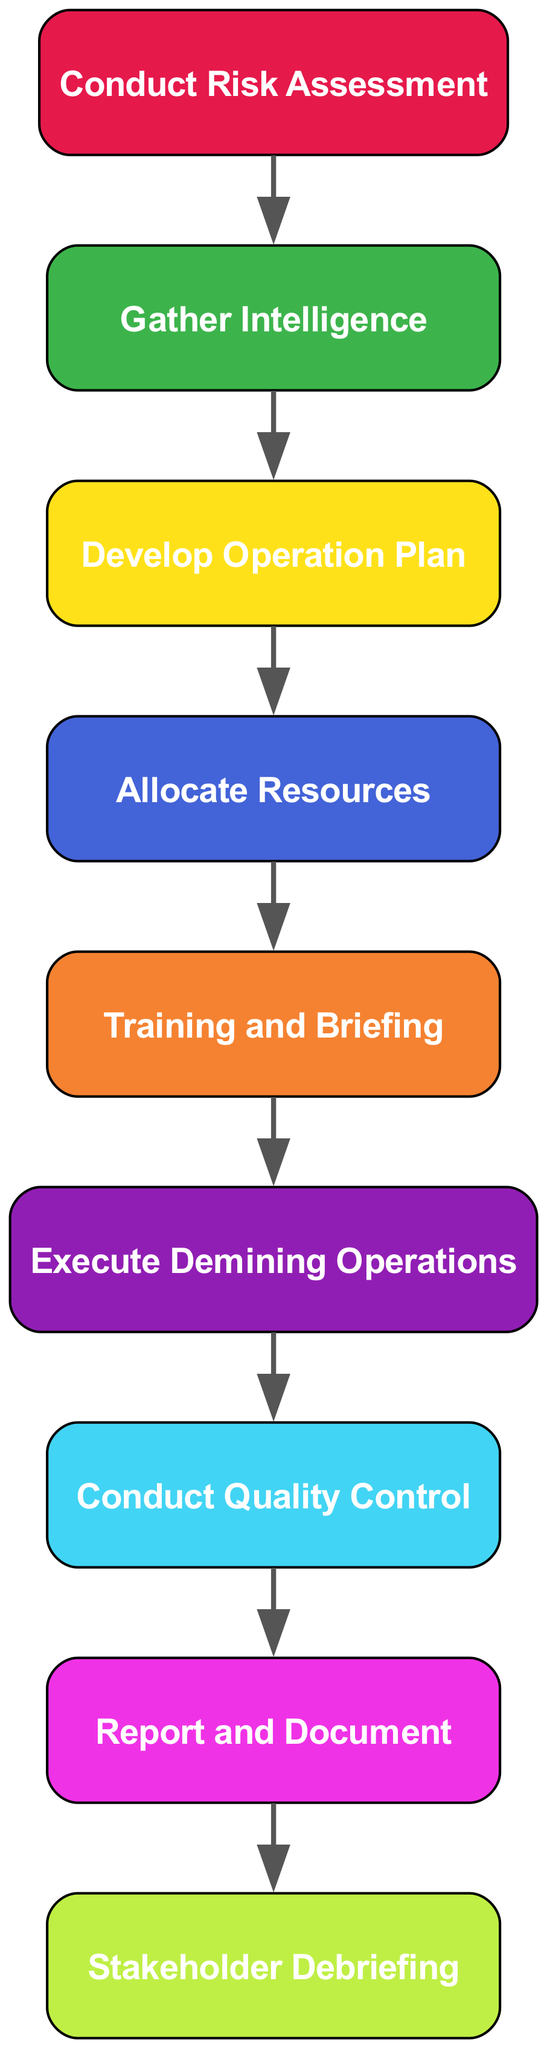What is the first step in the demining operation workflow? The diagram indicates that the first step is "Conduct Risk Assessment." This is the initial node in the flow chart, leading directly to the next step.
Answer: Conduct Risk Assessment How many total nodes are present in the diagram? By counting all the distinct steps listed in the diagram, including the starting point and the final actions, there are a total of nine nodes.
Answer: Nine Which step follows "Gather Intelligence"? The diagram shows that "Gather Intelligence" is directly linked to the next step which is "Develop Operation Plan." This is the flow from one node to another.
Answer: Develop Operation Plan What action occurs immediately after "Allocate Resources"? Following "Allocate Resources," the diagram flows to "Training and Briefing," indicating the necessary preparatory steps before executing the operation.
Answer: Training and Briefing At what stage is quality control performed during demining operations? According to the diagram, "Conduct Quality Control" is performed right after "Execute Demining Operations." This shows the sequence of ensuring effectiveness post-execution.
Answer: Conduct Quality Control Which step involves communicating outcomes to stakeholders? The last part of the workflow is "Stakeholder Debriefing," which signifies the communication of the operation's results to involved parties.
Answer: Stakeholder Debriefing What is the relationship between "Execute Demining Operations" and "Conduct Quality Control"? The diagram indicates that "Execute Demining Operations" leads directly to "Conduct Quality Control," establishing a sequential dependency between these two steps in the operation.
Answer: Sequential relationship Which step comes third in the sequence of the demining operation workflow? Counting from the first step "Conduct Risk Assessment," the third step is "Develop Operation Plan," as indicated by their arrangement in the flow chart.
Answer: Develop Operation Plan What is the last action described in the demining operation workflow? The final step in the workflow, as shown in the diagram, is "Report and Document," which reflects the need to maintain records of the operation.
Answer: Report and Document 